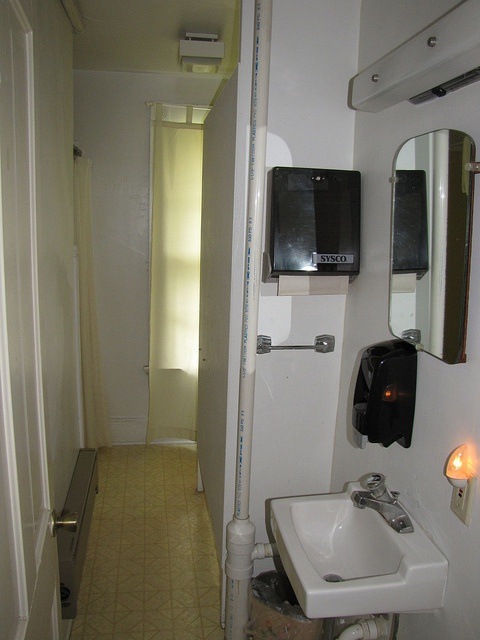Describe the objects in this image and their specific colors. I can see a sink in darkgreen, darkgray, and gray tones in this image. 